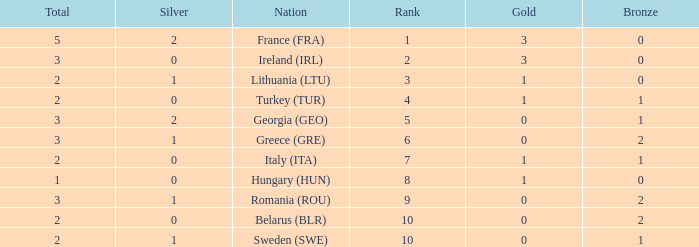What are the most bronze medals in a rank more than 1 with a total larger than 3? None. 